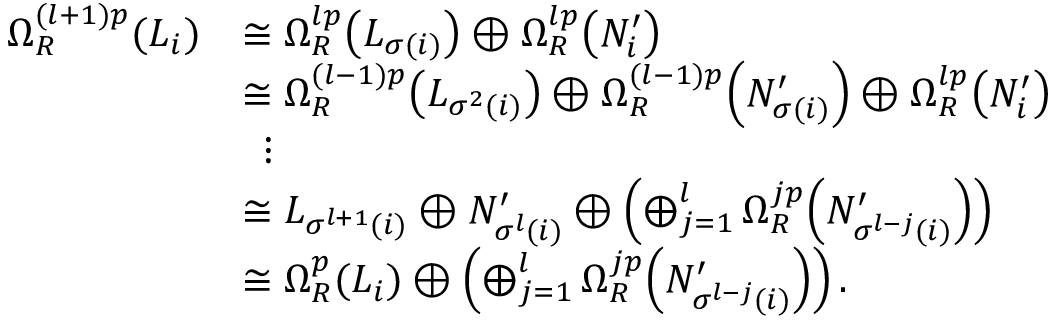<formula> <loc_0><loc_0><loc_500><loc_500>\begin{array} { r l } { \Omega _ { R } ^ { ( l + 1 ) p } ( L _ { i } ) } & { \cong \Omega _ { R } ^ { l p } \, \left ( L _ { \sigma ( i ) } \right ) \oplus \Omega _ { R } ^ { l p } \, \left ( N _ { i } ^ { \prime } \right ) } \\ & { \cong \Omega _ { R } ^ { ( l - 1 ) p } \, \left ( L _ { \sigma ^ { 2 } ( i ) } \right ) \oplus \Omega _ { R } ^ { ( l - 1 ) p } \, \left ( N _ { \sigma ( i ) } ^ { \prime } \right ) \oplus \Omega _ { R } ^ { l p } \, \left ( N _ { i } ^ { \prime } \right ) } \\ & { \ \, \vdots } \\ & { \cong L _ { \sigma ^ { l + 1 } ( i ) } \oplus N _ { \sigma ^ { l } ( i ) } ^ { \prime } \oplus \left ( \bigoplus _ { j = 1 } ^ { l } \Omega _ { R } ^ { j p } \, \left ( N _ { \sigma ^ { l - j } ( i ) } ^ { \prime } \right ) \right ) } \\ & { \cong \Omega _ { R } ^ { p } ( L _ { i } ) \oplus \left ( \bigoplus _ { j = 1 } ^ { l } \Omega _ { R } ^ { j p } \, \left ( N _ { \sigma ^ { l - j } ( i ) } ^ { \prime } \right ) \right ) . } \end{array}</formula> 